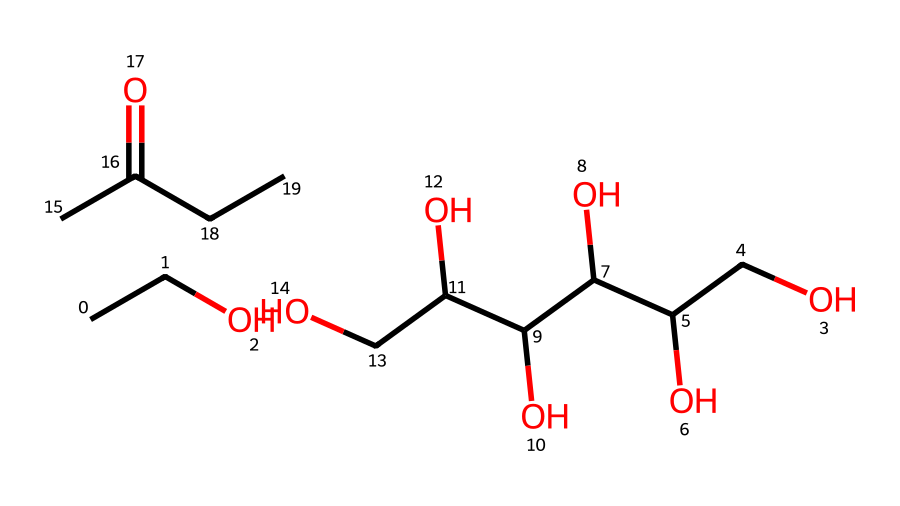What is the total number of carbon atoms in this molecule? Counting the carbon (C) atoms in the SMILES structure, there are 10 carbon atoms present in total.
Answer: 10 How many hydroxyl (OH) groups are present in this compound? By examining the structure, I can identify four hydroxyl (OH) groups from the multiple -OH connections in the chemical.
Answer: 4 Which functional group is primarily responsible for the sweet flavor of this compound? The presence of the hydroxyl (OH) groups indicates that this compound has alcohol functionalities, which contribute to its sweet flavor profile.
Answer: alcohol What is the molecular formula of this compound? Analyzing the atoms from the SMILES notation, the molecular formula derived is C10H20O6.
Answer: C10H20O6 Does this molecule have any double bonds? Upon reviewing the structure, there are no indications of double bonds present; all carbon connections appear to be single.
Answer: no What property might the presence of multiple alcohol groups suggest about the solubility of this compound? The multiple alcohol groups enhance hydrogen bonding capabilities, which typically increases the solubility in water or polar solvents.
Answer: high solubility What type of compound is represented in this SMILES notation? The SMILES structure indicates that it is an aliphatic alcohol due to the presence of hydroxyl groups attached to carbon chains.
Answer: aliphatic alcohol 